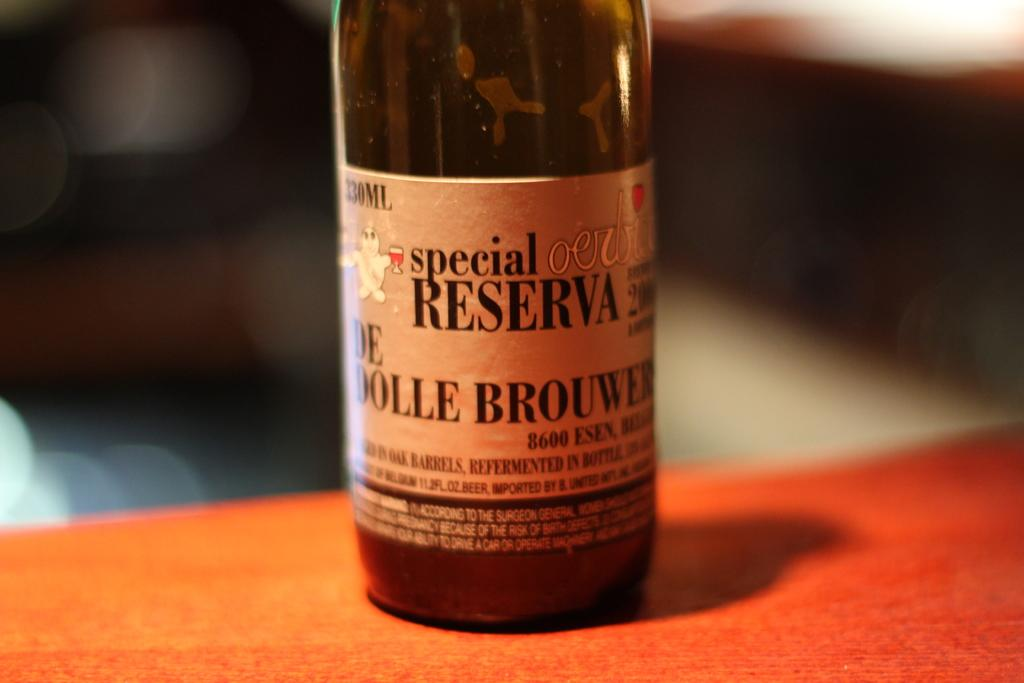<image>
Offer a succinct explanation of the picture presented. A special reserva drink on top of a counter 